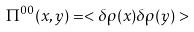Convert formula to latex. <formula><loc_0><loc_0><loc_500><loc_500>\Pi ^ { 0 0 } ( x , y ) = < \delta \rho ( x ) \delta \rho ( y ) ></formula> 